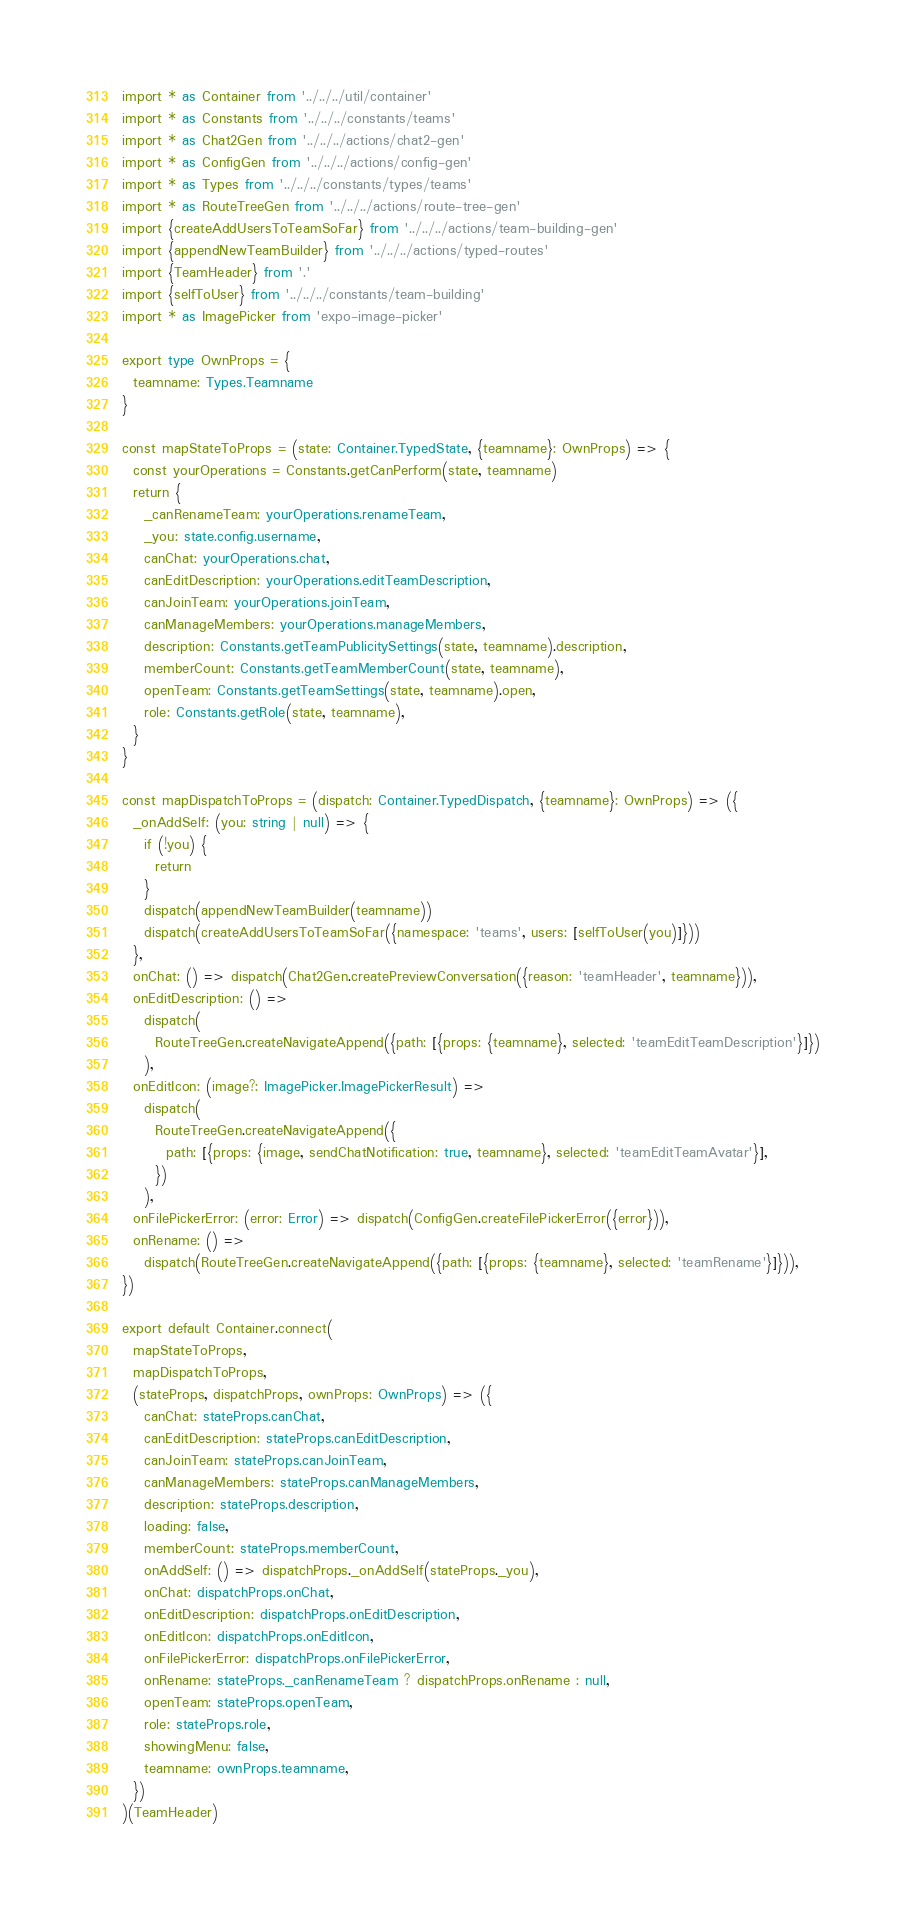Convert code to text. <code><loc_0><loc_0><loc_500><loc_500><_TypeScript_>import * as Container from '../../../util/container'
import * as Constants from '../../../constants/teams'
import * as Chat2Gen from '../../../actions/chat2-gen'
import * as ConfigGen from '../../../actions/config-gen'
import * as Types from '../../../constants/types/teams'
import * as RouteTreeGen from '../../../actions/route-tree-gen'
import {createAddUsersToTeamSoFar} from '../../../actions/team-building-gen'
import {appendNewTeamBuilder} from '../../../actions/typed-routes'
import {TeamHeader} from '.'
import {selfToUser} from '../../../constants/team-building'
import * as ImagePicker from 'expo-image-picker'

export type OwnProps = {
  teamname: Types.Teamname
}

const mapStateToProps = (state: Container.TypedState, {teamname}: OwnProps) => {
  const yourOperations = Constants.getCanPerform(state, teamname)
  return {
    _canRenameTeam: yourOperations.renameTeam,
    _you: state.config.username,
    canChat: yourOperations.chat,
    canEditDescription: yourOperations.editTeamDescription,
    canJoinTeam: yourOperations.joinTeam,
    canManageMembers: yourOperations.manageMembers,
    description: Constants.getTeamPublicitySettings(state, teamname).description,
    memberCount: Constants.getTeamMemberCount(state, teamname),
    openTeam: Constants.getTeamSettings(state, teamname).open,
    role: Constants.getRole(state, teamname),
  }
}

const mapDispatchToProps = (dispatch: Container.TypedDispatch, {teamname}: OwnProps) => ({
  _onAddSelf: (you: string | null) => {
    if (!you) {
      return
    }
    dispatch(appendNewTeamBuilder(teamname))
    dispatch(createAddUsersToTeamSoFar({namespace: 'teams', users: [selfToUser(you)]}))
  },
  onChat: () => dispatch(Chat2Gen.createPreviewConversation({reason: 'teamHeader', teamname})),
  onEditDescription: () =>
    dispatch(
      RouteTreeGen.createNavigateAppend({path: [{props: {teamname}, selected: 'teamEditTeamDescription'}]})
    ),
  onEditIcon: (image?: ImagePicker.ImagePickerResult) =>
    dispatch(
      RouteTreeGen.createNavigateAppend({
        path: [{props: {image, sendChatNotification: true, teamname}, selected: 'teamEditTeamAvatar'}],
      })
    ),
  onFilePickerError: (error: Error) => dispatch(ConfigGen.createFilePickerError({error})),
  onRename: () =>
    dispatch(RouteTreeGen.createNavigateAppend({path: [{props: {teamname}, selected: 'teamRename'}]})),
})

export default Container.connect(
  mapStateToProps,
  mapDispatchToProps,
  (stateProps, dispatchProps, ownProps: OwnProps) => ({
    canChat: stateProps.canChat,
    canEditDescription: stateProps.canEditDescription,
    canJoinTeam: stateProps.canJoinTeam,
    canManageMembers: stateProps.canManageMembers,
    description: stateProps.description,
    loading: false,
    memberCount: stateProps.memberCount,
    onAddSelf: () => dispatchProps._onAddSelf(stateProps._you),
    onChat: dispatchProps.onChat,
    onEditDescription: dispatchProps.onEditDescription,
    onEditIcon: dispatchProps.onEditIcon,
    onFilePickerError: dispatchProps.onFilePickerError,
    onRename: stateProps._canRenameTeam ? dispatchProps.onRename : null,
    openTeam: stateProps.openTeam,
    role: stateProps.role,
    showingMenu: false,
    teamname: ownProps.teamname,
  })
)(TeamHeader)
</code> 